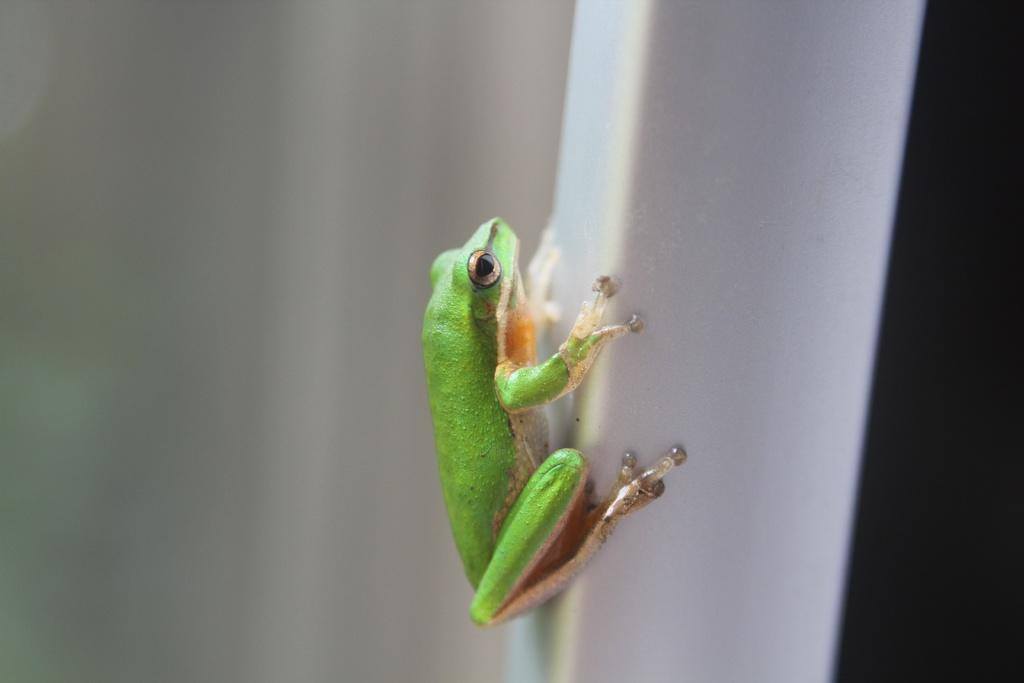What animal is present in the image? There is a frog in the image. What colors can be seen on the frog? The frog has green, cream, and brown colors. What is the frog sitting on in the image? The frog is on a white object. How would you describe the background of the image? The background of the image is white and black. What is the frog's desire for profit in the image? There is no indication of the frog having any desires or seeking profit in the image. 